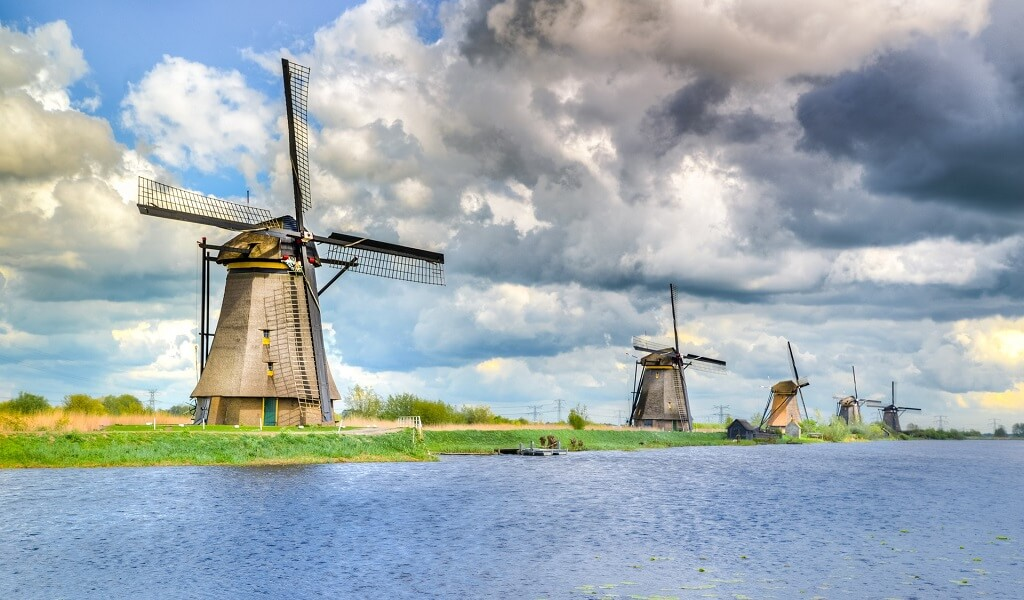Describe the following image. The image showcases the historic Kinderdijk Windmills in the Netherlands, a UNESCO World Heritage site. These iconic windmills, constructed primarily from wood, are aligned neatly along a water canal. Each mill is equipped with four large sails used historically for draining the surrounding floodplains. This setting not only provides a glimpse into Dutch engineering but also into 18th-century environmental management practices. The image, taken from a low angle, offers a majestic view against a backdrop of a dynamic sky, scattered with clouds, and the lush greenery nearby, emphasizing the blend of natural beauty with historical architecture. 